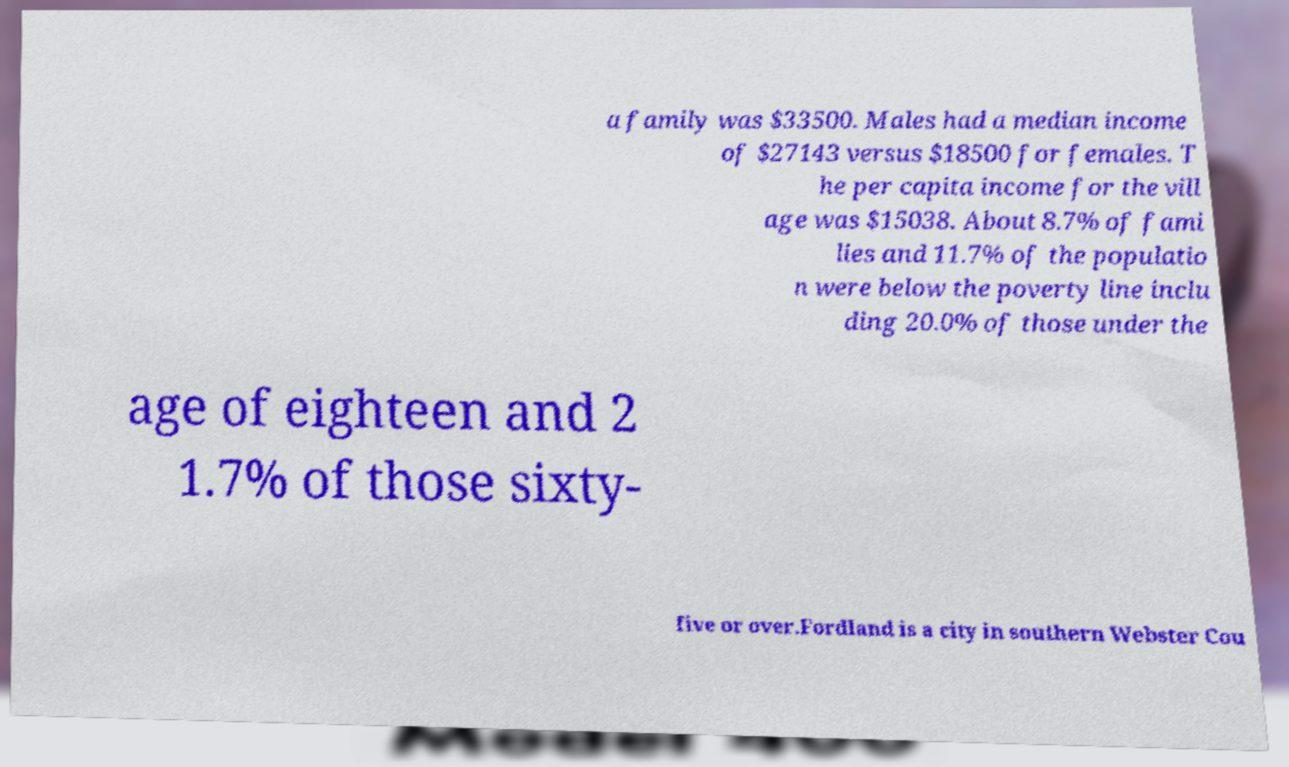Can you accurately transcribe the text from the provided image for me? a family was $33500. Males had a median income of $27143 versus $18500 for females. T he per capita income for the vill age was $15038. About 8.7% of fami lies and 11.7% of the populatio n were below the poverty line inclu ding 20.0% of those under the age of eighteen and 2 1.7% of those sixty- five or over.Fordland is a city in southern Webster Cou 